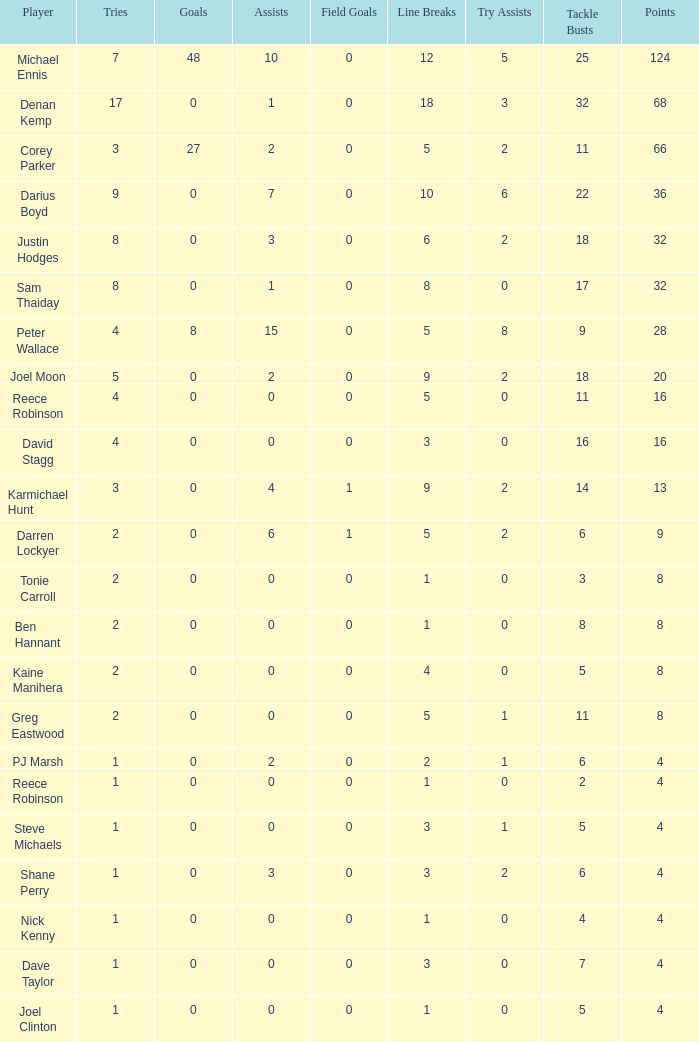What is the number of goals Dave Taylor, who has more than 1 tries, has? None. 